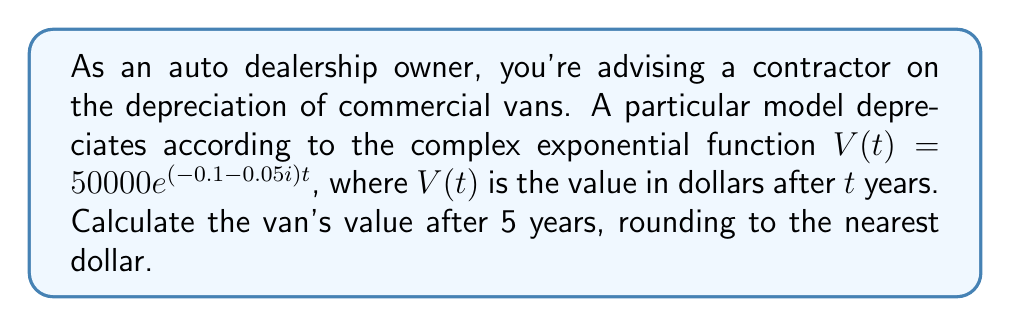Could you help me with this problem? To solve this problem, we need to use the given complex exponential function and evaluate it at $t = 5$ years. Let's break it down step-by-step:

1) The given function is $V(t) = 50000e^{(-0.1 - 0.05i)t}$

2) We need to calculate $V(5)$:
   $V(5) = 50000e^{(-0.1 - 0.05i)5}$

3) Simplify the exponent:
   $V(5) = 50000e^{-0.5 - 0.25i}$

4) Recall Euler's formula: $e^{a+bi} = e^a(\cos b + i\sin b)$
   Here, $a = -0.5$ and $b = -0.25$

5) Apply Euler's formula:
   $V(5) = 50000e^{-0.5}(\cos(-0.25) + i\sin(-0.25))$

6) Calculate the real components:
   $e^{-0.5} \approx 0.6065$
   $\cos(-0.25) \approx 0.9689$
   $\sin(-0.25) \approx -0.2474$

7) Substitute these values:
   $V(5) \approx 50000 \cdot 0.6065 \cdot (0.9689 - 0.2474i)$

8) Multiply:
   $V(5) \approx 30325 \cdot (0.9689 - 0.2474i)$
   $V(5) \approx 29382 - 7502i$

9) To get the actual value, we need the magnitude of this complex number:
   $|V(5)| = \sqrt{29382^2 + 7502^2} \approx 30325$

10) Rounding to the nearest dollar:
    $V(5) \approx 30325$
Answer: $30325 